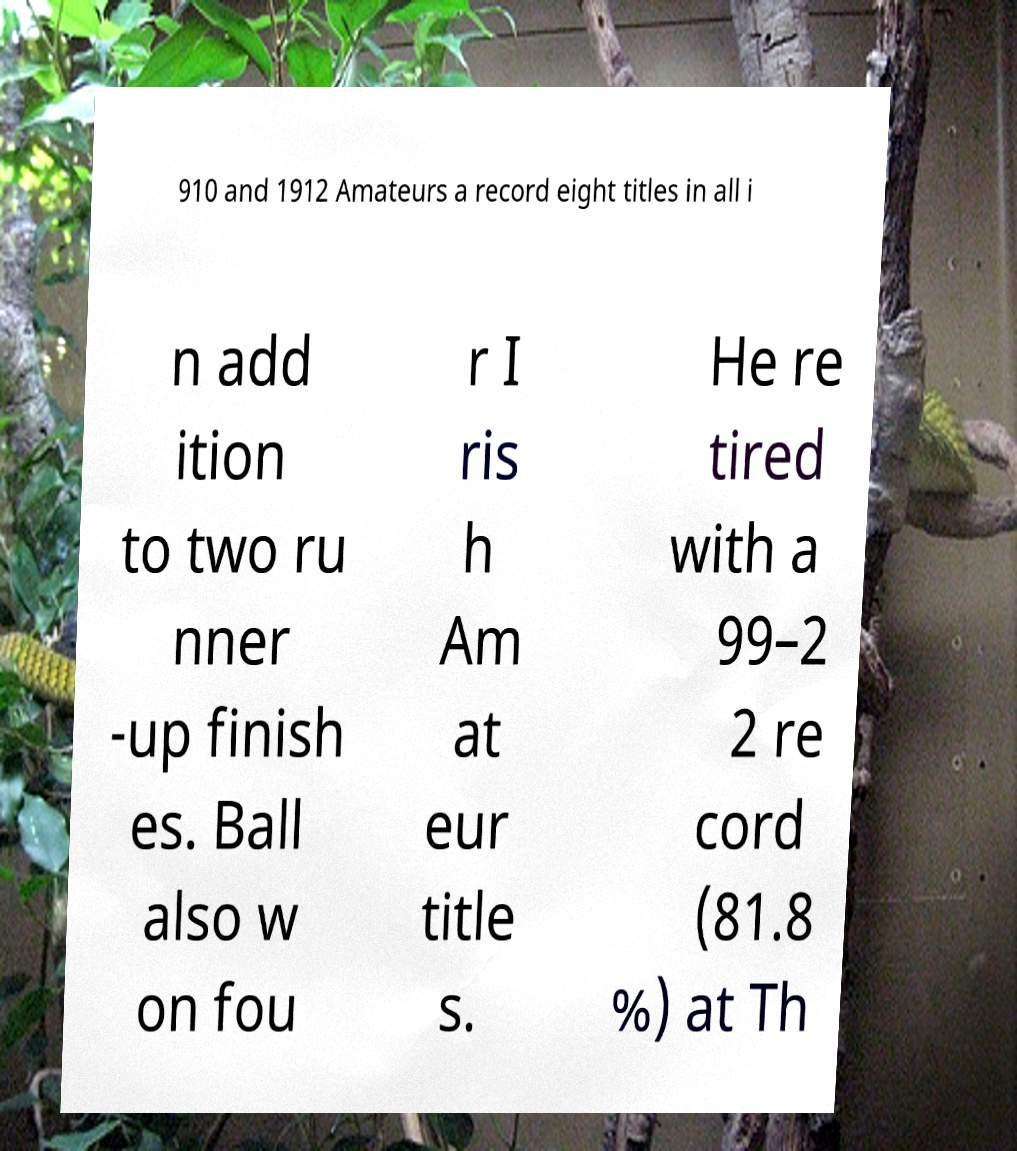What messages or text are displayed in this image? I need them in a readable, typed format. 910 and 1912 Amateurs a record eight titles in all i n add ition to two ru nner -up finish es. Ball also w on fou r I ris h Am at eur title s. He re tired with a 99–2 2 re cord (81.8 %) at Th 